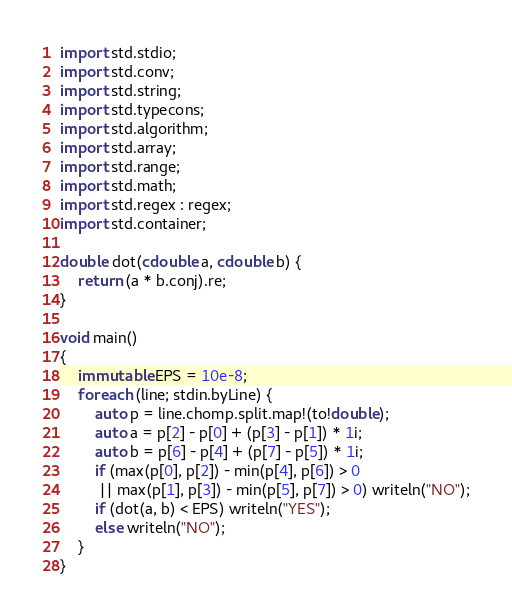<code> <loc_0><loc_0><loc_500><loc_500><_D_>import std.stdio;
import std.conv;
import std.string;
import std.typecons;
import std.algorithm;
import std.array;
import std.range;
import std.math;
import std.regex : regex;
import std.container;

double dot(cdouble a, cdouble b) {
	return (a * b.conj).re;
}

void main()
{
	immutable EPS = 10e-8;
	foreach (line; stdin.byLine) {
		auto p = line.chomp.split.map!(to!double);
		auto a = p[2] - p[0] + (p[3] - p[1]) * 1i;
		auto b = p[6] - p[4] + (p[7] - p[5]) * 1i;
		if (max(p[0], p[2]) - min(p[4], p[6]) > 0
		 || max(p[1], p[3]) - min(p[5], p[7]) > 0) writeln("NO");
		if (dot(a, b) < EPS) writeln("YES");
		else writeln("NO");
	}
}</code> 